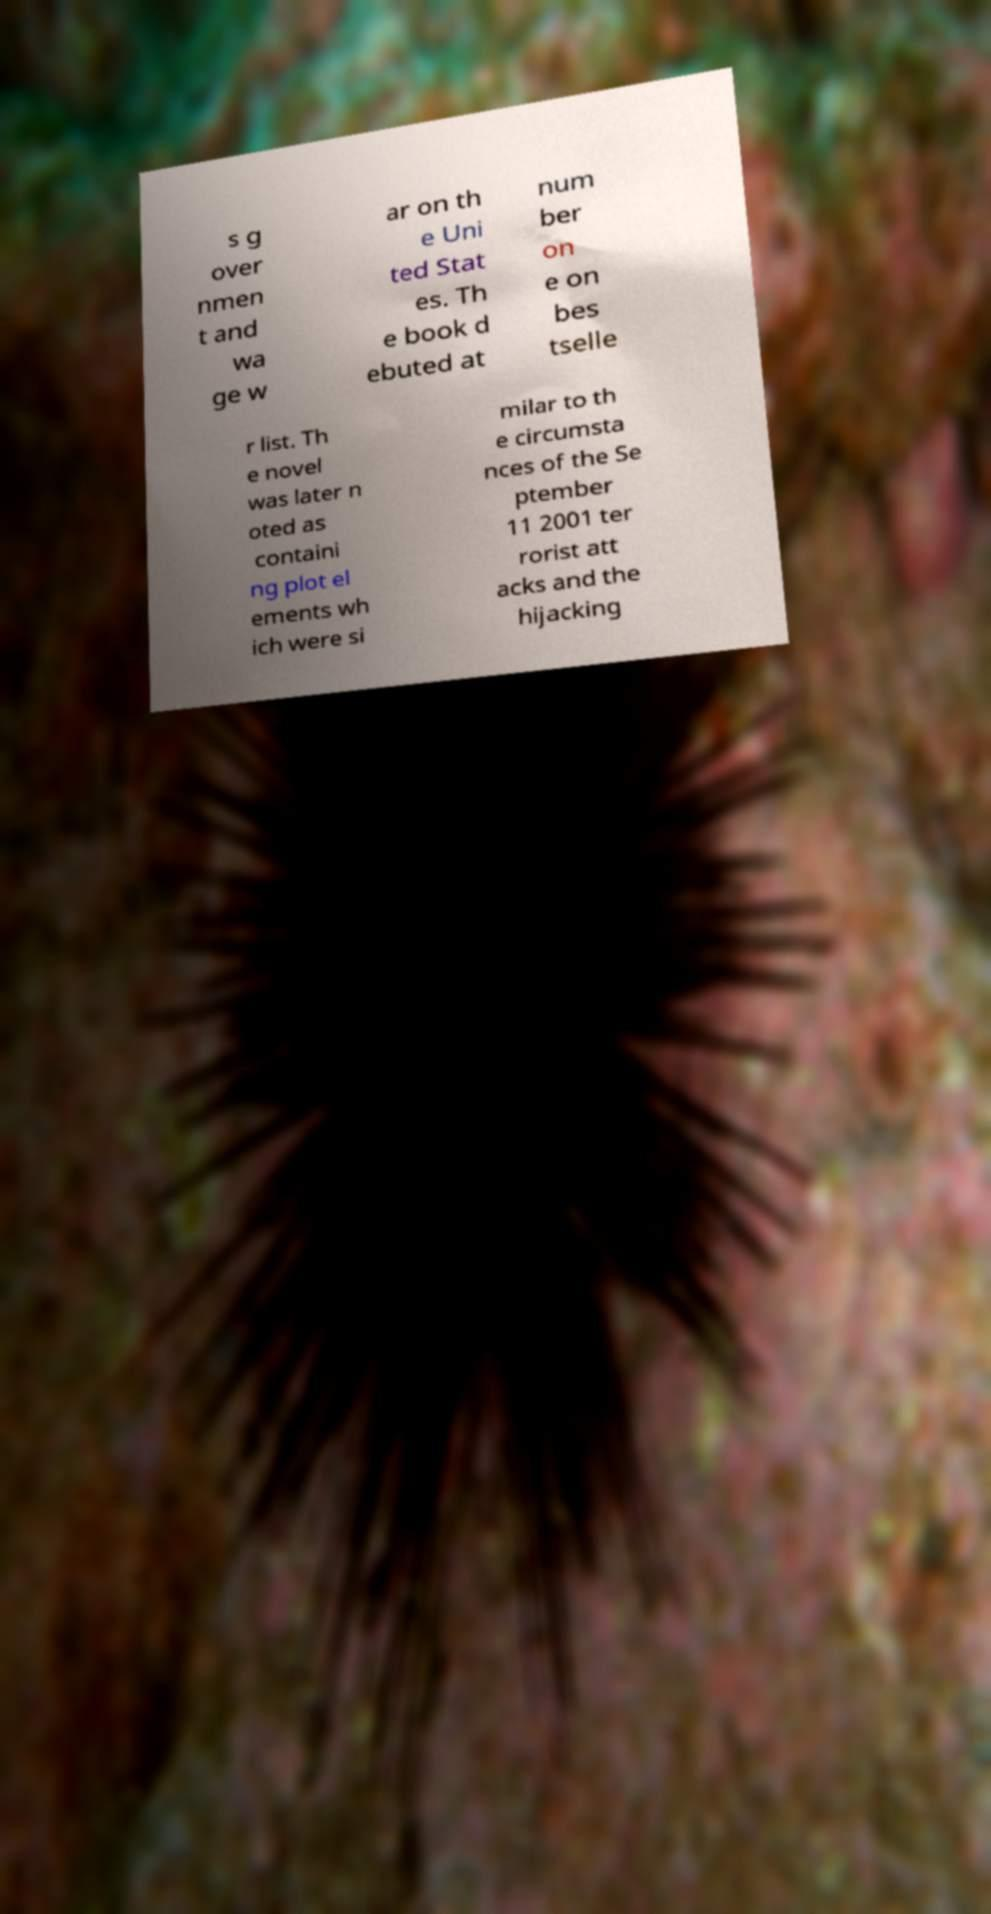Please identify and transcribe the text found in this image. s g over nmen t and wa ge w ar on th e Uni ted Stat es. Th e book d ebuted at num ber on e on bes tselle r list. Th e novel was later n oted as containi ng plot el ements wh ich were si milar to th e circumsta nces of the Se ptember 11 2001 ter rorist att acks and the hijacking 